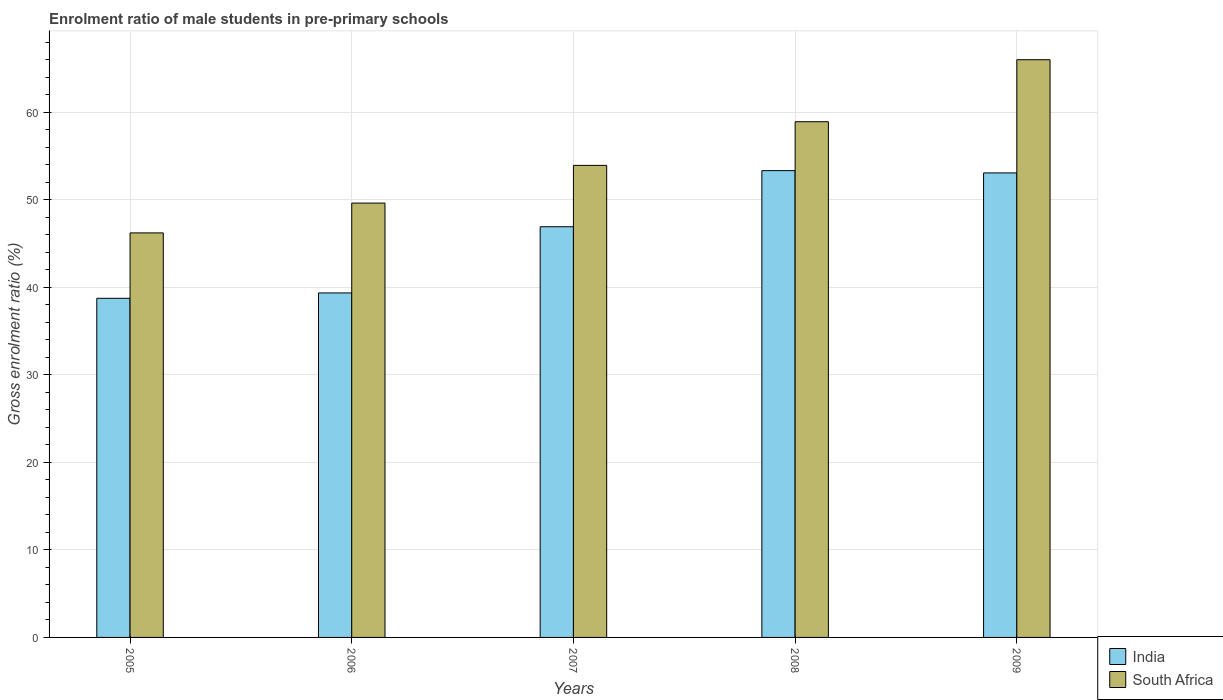How many groups of bars are there?
Your answer should be compact. 5. Are the number of bars per tick equal to the number of legend labels?
Make the answer very short. Yes. How many bars are there on the 2nd tick from the left?
Give a very brief answer. 2. How many bars are there on the 3rd tick from the right?
Your answer should be compact. 2. In how many cases, is the number of bars for a given year not equal to the number of legend labels?
Ensure brevity in your answer.  0. What is the enrolment ratio of male students in pre-primary schools in South Africa in 2009?
Make the answer very short. 65.99. Across all years, what is the maximum enrolment ratio of male students in pre-primary schools in South Africa?
Make the answer very short. 65.99. Across all years, what is the minimum enrolment ratio of male students in pre-primary schools in India?
Ensure brevity in your answer.  38.74. In which year was the enrolment ratio of male students in pre-primary schools in India maximum?
Ensure brevity in your answer.  2008. What is the total enrolment ratio of male students in pre-primary schools in South Africa in the graph?
Ensure brevity in your answer.  274.64. What is the difference between the enrolment ratio of male students in pre-primary schools in India in 2007 and that in 2008?
Your answer should be compact. -6.41. What is the difference between the enrolment ratio of male students in pre-primary schools in South Africa in 2008 and the enrolment ratio of male students in pre-primary schools in India in 2005?
Provide a succinct answer. 20.17. What is the average enrolment ratio of male students in pre-primary schools in South Africa per year?
Keep it short and to the point. 54.93. In the year 2006, what is the difference between the enrolment ratio of male students in pre-primary schools in South Africa and enrolment ratio of male students in pre-primary schools in India?
Keep it short and to the point. 10.26. What is the ratio of the enrolment ratio of male students in pre-primary schools in South Africa in 2005 to that in 2006?
Your response must be concise. 0.93. Is the enrolment ratio of male students in pre-primary schools in India in 2006 less than that in 2007?
Offer a terse response. Yes. Is the difference between the enrolment ratio of male students in pre-primary schools in South Africa in 2007 and 2008 greater than the difference between the enrolment ratio of male students in pre-primary schools in India in 2007 and 2008?
Provide a short and direct response. Yes. What is the difference between the highest and the second highest enrolment ratio of male students in pre-primary schools in India?
Keep it short and to the point. 0.26. What is the difference between the highest and the lowest enrolment ratio of male students in pre-primary schools in South Africa?
Offer a terse response. 19.78. What does the 2nd bar from the left in 2008 represents?
Offer a very short reply. South Africa. What does the 2nd bar from the right in 2006 represents?
Your answer should be compact. India. Are all the bars in the graph horizontal?
Give a very brief answer. No. What is the difference between two consecutive major ticks on the Y-axis?
Make the answer very short. 10. Does the graph contain any zero values?
Your answer should be very brief. No. How many legend labels are there?
Provide a succinct answer. 2. How are the legend labels stacked?
Your response must be concise. Vertical. What is the title of the graph?
Offer a terse response. Enrolment ratio of male students in pre-primary schools. Does "China" appear as one of the legend labels in the graph?
Keep it short and to the point. No. What is the label or title of the X-axis?
Offer a very short reply. Years. What is the Gross enrolment ratio (%) of India in 2005?
Your response must be concise. 38.74. What is the Gross enrolment ratio (%) in South Africa in 2005?
Your response must be concise. 46.21. What is the Gross enrolment ratio (%) of India in 2006?
Provide a succinct answer. 39.35. What is the Gross enrolment ratio (%) in South Africa in 2006?
Provide a short and direct response. 49.61. What is the Gross enrolment ratio (%) in India in 2007?
Offer a terse response. 46.91. What is the Gross enrolment ratio (%) in South Africa in 2007?
Make the answer very short. 53.92. What is the Gross enrolment ratio (%) of India in 2008?
Offer a terse response. 53.32. What is the Gross enrolment ratio (%) of South Africa in 2008?
Offer a very short reply. 58.91. What is the Gross enrolment ratio (%) of India in 2009?
Your answer should be compact. 53.06. What is the Gross enrolment ratio (%) of South Africa in 2009?
Your response must be concise. 65.99. Across all years, what is the maximum Gross enrolment ratio (%) of India?
Offer a terse response. 53.32. Across all years, what is the maximum Gross enrolment ratio (%) in South Africa?
Your answer should be compact. 65.99. Across all years, what is the minimum Gross enrolment ratio (%) of India?
Keep it short and to the point. 38.74. Across all years, what is the minimum Gross enrolment ratio (%) of South Africa?
Offer a very short reply. 46.21. What is the total Gross enrolment ratio (%) in India in the graph?
Provide a succinct answer. 231.38. What is the total Gross enrolment ratio (%) in South Africa in the graph?
Make the answer very short. 274.64. What is the difference between the Gross enrolment ratio (%) of India in 2005 and that in 2006?
Offer a very short reply. -0.61. What is the difference between the Gross enrolment ratio (%) in South Africa in 2005 and that in 2006?
Ensure brevity in your answer.  -3.4. What is the difference between the Gross enrolment ratio (%) of India in 2005 and that in 2007?
Give a very brief answer. -8.17. What is the difference between the Gross enrolment ratio (%) in South Africa in 2005 and that in 2007?
Provide a short and direct response. -7.71. What is the difference between the Gross enrolment ratio (%) of India in 2005 and that in 2008?
Your response must be concise. -14.58. What is the difference between the Gross enrolment ratio (%) in South Africa in 2005 and that in 2008?
Your answer should be very brief. -12.7. What is the difference between the Gross enrolment ratio (%) in India in 2005 and that in 2009?
Give a very brief answer. -14.32. What is the difference between the Gross enrolment ratio (%) of South Africa in 2005 and that in 2009?
Keep it short and to the point. -19.78. What is the difference between the Gross enrolment ratio (%) in India in 2006 and that in 2007?
Offer a terse response. -7.56. What is the difference between the Gross enrolment ratio (%) in South Africa in 2006 and that in 2007?
Offer a very short reply. -4.31. What is the difference between the Gross enrolment ratio (%) of India in 2006 and that in 2008?
Provide a short and direct response. -13.97. What is the difference between the Gross enrolment ratio (%) of South Africa in 2006 and that in 2008?
Offer a very short reply. -9.29. What is the difference between the Gross enrolment ratio (%) in India in 2006 and that in 2009?
Keep it short and to the point. -13.71. What is the difference between the Gross enrolment ratio (%) in South Africa in 2006 and that in 2009?
Provide a succinct answer. -16.38. What is the difference between the Gross enrolment ratio (%) in India in 2007 and that in 2008?
Your answer should be very brief. -6.41. What is the difference between the Gross enrolment ratio (%) in South Africa in 2007 and that in 2008?
Your answer should be compact. -4.99. What is the difference between the Gross enrolment ratio (%) of India in 2007 and that in 2009?
Offer a very short reply. -6.15. What is the difference between the Gross enrolment ratio (%) in South Africa in 2007 and that in 2009?
Your answer should be very brief. -12.07. What is the difference between the Gross enrolment ratio (%) in India in 2008 and that in 2009?
Keep it short and to the point. 0.26. What is the difference between the Gross enrolment ratio (%) of South Africa in 2008 and that in 2009?
Ensure brevity in your answer.  -7.08. What is the difference between the Gross enrolment ratio (%) in India in 2005 and the Gross enrolment ratio (%) in South Africa in 2006?
Provide a short and direct response. -10.88. What is the difference between the Gross enrolment ratio (%) in India in 2005 and the Gross enrolment ratio (%) in South Africa in 2007?
Your response must be concise. -15.18. What is the difference between the Gross enrolment ratio (%) in India in 2005 and the Gross enrolment ratio (%) in South Africa in 2008?
Provide a succinct answer. -20.17. What is the difference between the Gross enrolment ratio (%) in India in 2005 and the Gross enrolment ratio (%) in South Africa in 2009?
Keep it short and to the point. -27.26. What is the difference between the Gross enrolment ratio (%) in India in 2006 and the Gross enrolment ratio (%) in South Africa in 2007?
Keep it short and to the point. -14.57. What is the difference between the Gross enrolment ratio (%) of India in 2006 and the Gross enrolment ratio (%) of South Africa in 2008?
Give a very brief answer. -19.56. What is the difference between the Gross enrolment ratio (%) of India in 2006 and the Gross enrolment ratio (%) of South Africa in 2009?
Give a very brief answer. -26.64. What is the difference between the Gross enrolment ratio (%) of India in 2007 and the Gross enrolment ratio (%) of South Africa in 2008?
Give a very brief answer. -12. What is the difference between the Gross enrolment ratio (%) in India in 2007 and the Gross enrolment ratio (%) in South Africa in 2009?
Your response must be concise. -19.08. What is the difference between the Gross enrolment ratio (%) of India in 2008 and the Gross enrolment ratio (%) of South Africa in 2009?
Offer a terse response. -12.67. What is the average Gross enrolment ratio (%) of India per year?
Keep it short and to the point. 46.28. What is the average Gross enrolment ratio (%) in South Africa per year?
Give a very brief answer. 54.93. In the year 2005, what is the difference between the Gross enrolment ratio (%) in India and Gross enrolment ratio (%) in South Africa?
Make the answer very short. -7.47. In the year 2006, what is the difference between the Gross enrolment ratio (%) of India and Gross enrolment ratio (%) of South Africa?
Provide a succinct answer. -10.26. In the year 2007, what is the difference between the Gross enrolment ratio (%) in India and Gross enrolment ratio (%) in South Africa?
Offer a very short reply. -7.01. In the year 2008, what is the difference between the Gross enrolment ratio (%) in India and Gross enrolment ratio (%) in South Africa?
Your response must be concise. -5.59. In the year 2009, what is the difference between the Gross enrolment ratio (%) of India and Gross enrolment ratio (%) of South Africa?
Provide a short and direct response. -12.93. What is the ratio of the Gross enrolment ratio (%) in India in 2005 to that in 2006?
Your answer should be compact. 0.98. What is the ratio of the Gross enrolment ratio (%) in South Africa in 2005 to that in 2006?
Offer a very short reply. 0.93. What is the ratio of the Gross enrolment ratio (%) of India in 2005 to that in 2007?
Provide a succinct answer. 0.83. What is the ratio of the Gross enrolment ratio (%) in South Africa in 2005 to that in 2007?
Make the answer very short. 0.86. What is the ratio of the Gross enrolment ratio (%) in India in 2005 to that in 2008?
Make the answer very short. 0.73. What is the ratio of the Gross enrolment ratio (%) of South Africa in 2005 to that in 2008?
Offer a terse response. 0.78. What is the ratio of the Gross enrolment ratio (%) in India in 2005 to that in 2009?
Provide a succinct answer. 0.73. What is the ratio of the Gross enrolment ratio (%) in South Africa in 2005 to that in 2009?
Provide a succinct answer. 0.7. What is the ratio of the Gross enrolment ratio (%) in India in 2006 to that in 2007?
Ensure brevity in your answer.  0.84. What is the ratio of the Gross enrolment ratio (%) in South Africa in 2006 to that in 2007?
Your answer should be very brief. 0.92. What is the ratio of the Gross enrolment ratio (%) in India in 2006 to that in 2008?
Your answer should be compact. 0.74. What is the ratio of the Gross enrolment ratio (%) of South Africa in 2006 to that in 2008?
Keep it short and to the point. 0.84. What is the ratio of the Gross enrolment ratio (%) in India in 2006 to that in 2009?
Your answer should be very brief. 0.74. What is the ratio of the Gross enrolment ratio (%) in South Africa in 2006 to that in 2009?
Provide a short and direct response. 0.75. What is the ratio of the Gross enrolment ratio (%) of India in 2007 to that in 2008?
Offer a very short reply. 0.88. What is the ratio of the Gross enrolment ratio (%) of South Africa in 2007 to that in 2008?
Ensure brevity in your answer.  0.92. What is the ratio of the Gross enrolment ratio (%) of India in 2007 to that in 2009?
Ensure brevity in your answer.  0.88. What is the ratio of the Gross enrolment ratio (%) of South Africa in 2007 to that in 2009?
Your answer should be compact. 0.82. What is the ratio of the Gross enrolment ratio (%) of South Africa in 2008 to that in 2009?
Provide a short and direct response. 0.89. What is the difference between the highest and the second highest Gross enrolment ratio (%) in India?
Your response must be concise. 0.26. What is the difference between the highest and the second highest Gross enrolment ratio (%) in South Africa?
Offer a terse response. 7.08. What is the difference between the highest and the lowest Gross enrolment ratio (%) of India?
Offer a very short reply. 14.58. What is the difference between the highest and the lowest Gross enrolment ratio (%) of South Africa?
Offer a very short reply. 19.78. 